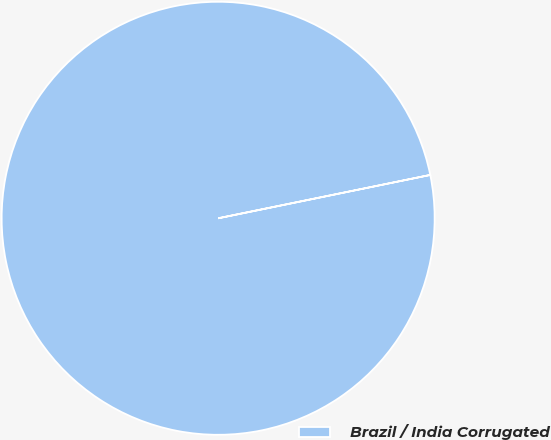Convert chart. <chart><loc_0><loc_0><loc_500><loc_500><pie_chart><fcel>Brazil / India Corrugated<nl><fcel>100.0%<nl></chart> 